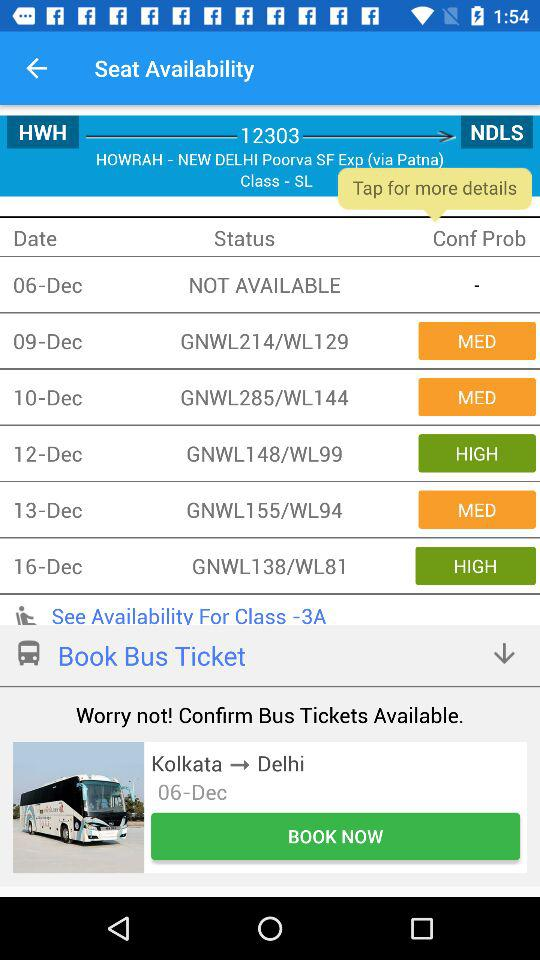How many travelers are there?
When the provided information is insufficient, respond with <no answer>. <no answer> 